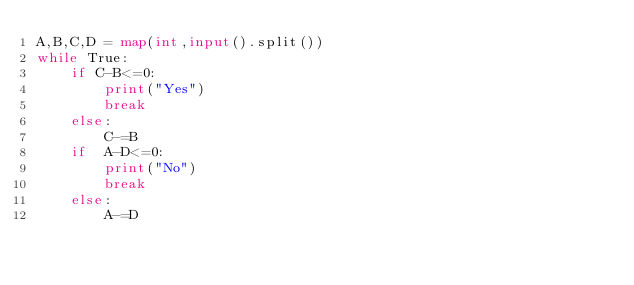Convert code to text. <code><loc_0><loc_0><loc_500><loc_500><_Python_>A,B,C,D = map(int,input().split())
while True:
    if C-B<=0:
        print("Yes")
        break
    else:
        C-=B
    if  A-D<=0:
        print("No")
        break
    else:
        A-=D</code> 